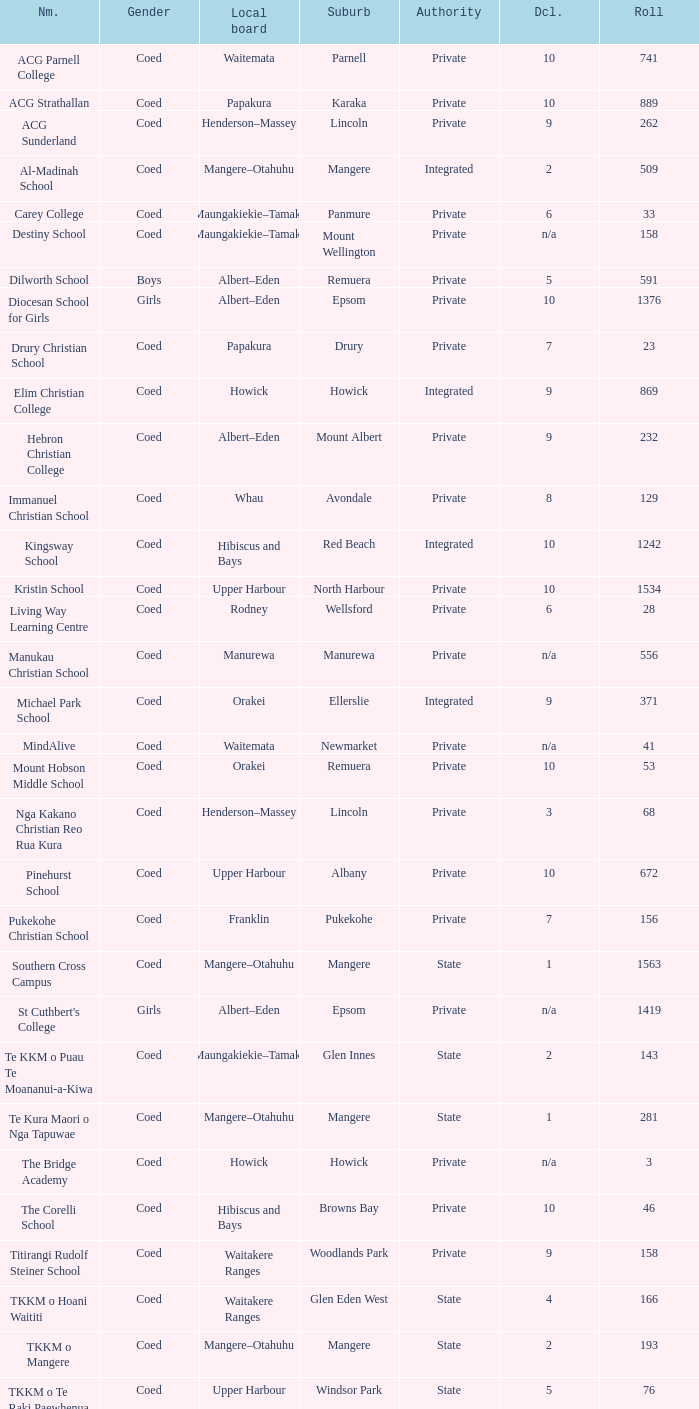What is the name of the suburb with a roll of 741? Parnell. 